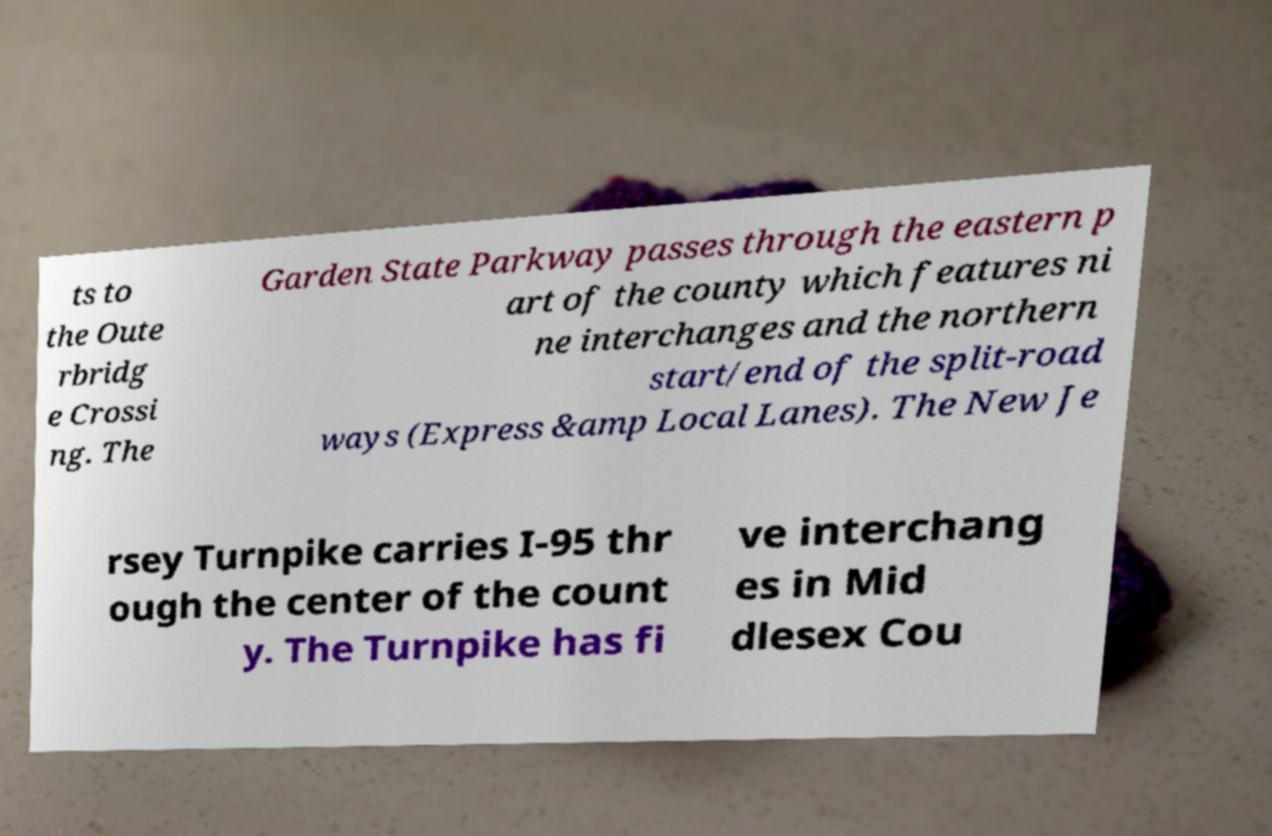Can you accurately transcribe the text from the provided image for me? ts to the Oute rbridg e Crossi ng. The Garden State Parkway passes through the eastern p art of the county which features ni ne interchanges and the northern start/end of the split-road ways (Express &amp Local Lanes). The New Je rsey Turnpike carries I-95 thr ough the center of the count y. The Turnpike has fi ve interchang es in Mid dlesex Cou 